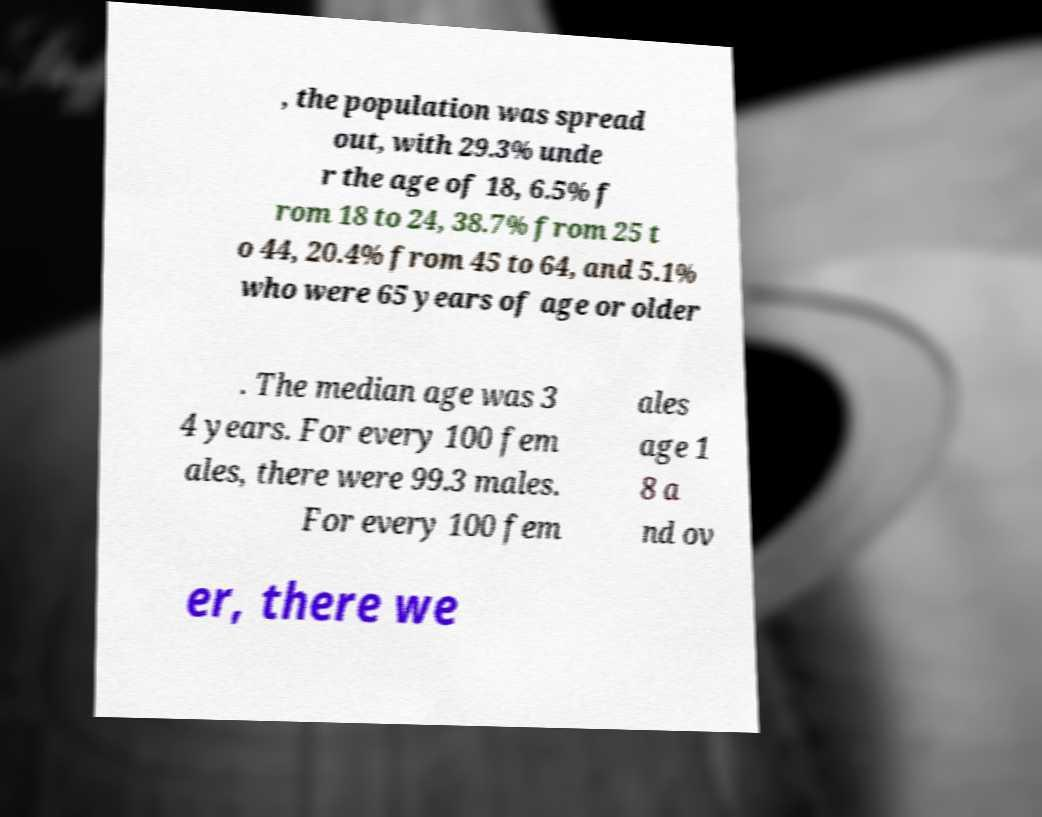I need the written content from this picture converted into text. Can you do that? , the population was spread out, with 29.3% unde r the age of 18, 6.5% f rom 18 to 24, 38.7% from 25 t o 44, 20.4% from 45 to 64, and 5.1% who were 65 years of age or older . The median age was 3 4 years. For every 100 fem ales, there were 99.3 males. For every 100 fem ales age 1 8 a nd ov er, there we 